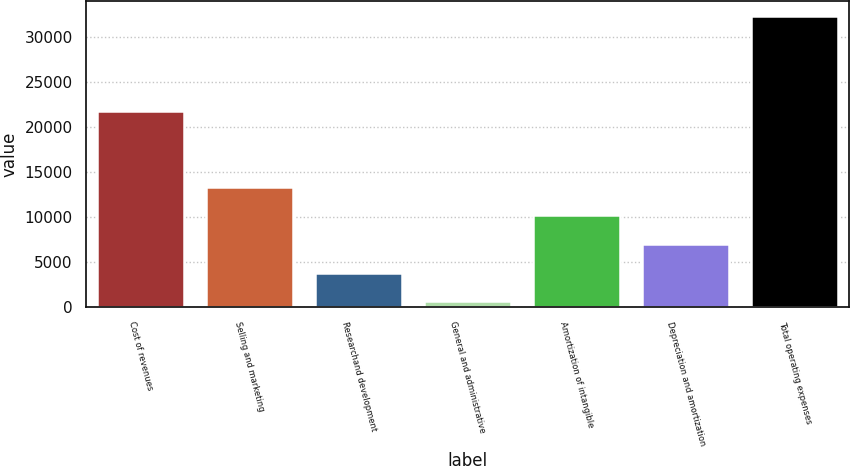<chart> <loc_0><loc_0><loc_500><loc_500><bar_chart><fcel>Cost of revenues<fcel>Selling and marketing<fcel>Researchand development<fcel>General and administrative<fcel>Amortization of intangible<fcel>Depreciation and amortization<fcel>Total operating expenses<nl><fcel>21806<fcel>13368.4<fcel>3843.1<fcel>668<fcel>10193.3<fcel>7018.2<fcel>32419<nl></chart> 